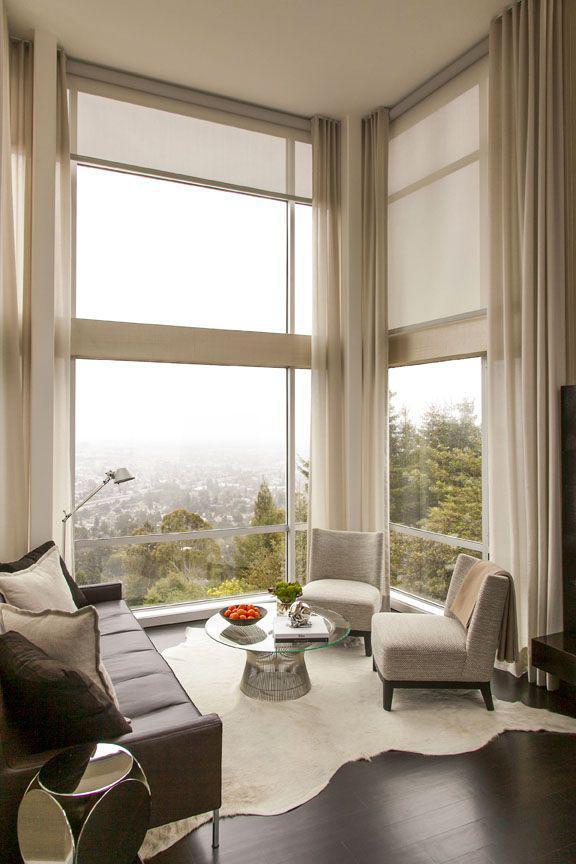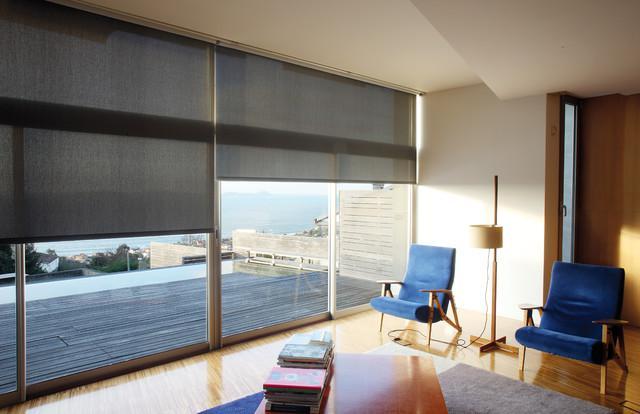The first image is the image on the left, the second image is the image on the right. Given the left and right images, does the statement "There are no less than five blinds." hold true? Answer yes or no. No. 